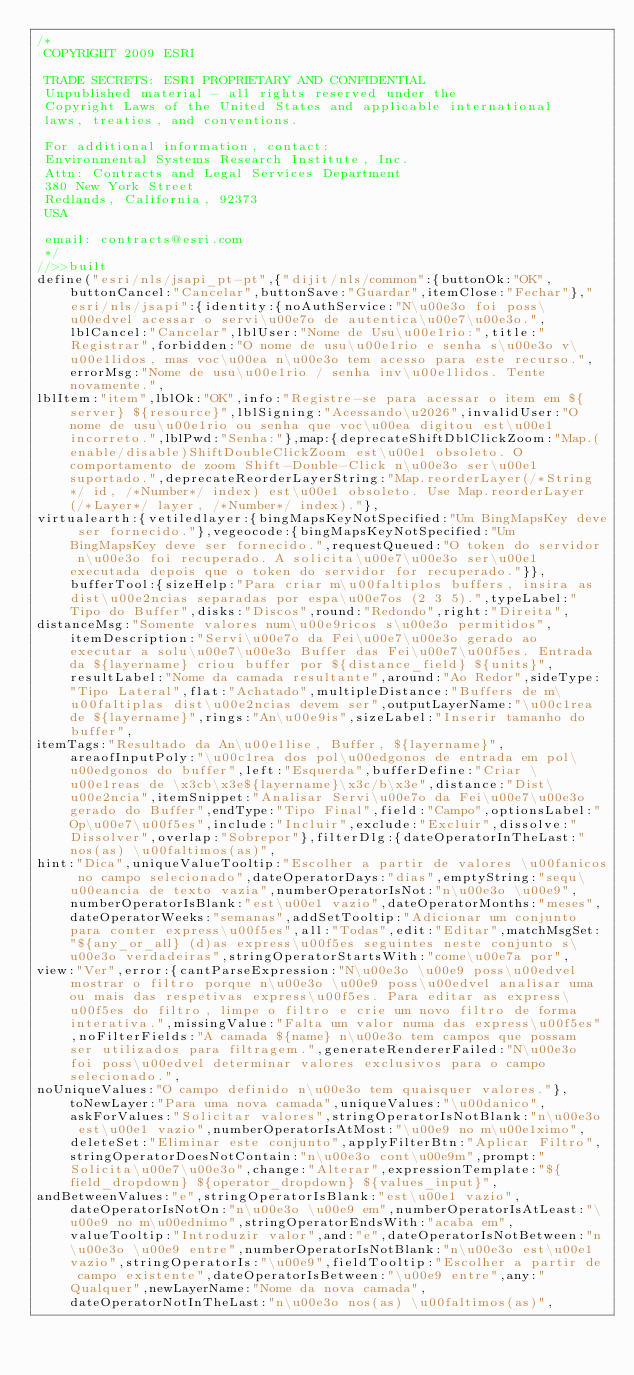<code> <loc_0><loc_0><loc_500><loc_500><_JavaScript_>/*
 COPYRIGHT 2009 ESRI

 TRADE SECRETS: ESRI PROPRIETARY AND CONFIDENTIAL
 Unpublished material - all rights reserved under the
 Copyright Laws of the United States and applicable international
 laws, treaties, and conventions.

 For additional information, contact:
 Environmental Systems Research Institute, Inc.
 Attn: Contracts and Legal Services Department
 380 New York Street
 Redlands, California, 92373
 USA

 email: contracts@esri.com
 */
//>>built
define("esri/nls/jsapi_pt-pt",{"dijit/nls/common":{buttonOk:"OK",buttonCancel:"Cancelar",buttonSave:"Guardar",itemClose:"Fechar"},"esri/nls/jsapi":{identity:{noAuthService:"N\u00e3o foi poss\u00edvel acessar o servi\u00e7o de autentica\u00e7\u00e3o.",lblCancel:"Cancelar",lblUser:"Nome de Usu\u00e1rio:",title:"Registrar",forbidden:"O nome de usu\u00e1rio e senha s\u00e3o v\u00e1lidos, mas voc\u00ea n\u00e3o tem acesso para este recurso.",errorMsg:"Nome de usu\u00e1rio / senha inv\u00e1lidos. Tente novamente.",
lblItem:"item",lblOk:"OK",info:"Registre-se para acessar o item em ${server} ${resource}",lblSigning:"Acessando\u2026",invalidUser:"O nome de usu\u00e1rio ou senha que voc\u00ea digitou est\u00e1 incorreto.",lblPwd:"Senha:"},map:{deprecateShiftDblClickZoom:"Map.(enable/disable)ShiftDoubleClickZoom est\u00e1 obsoleto. O comportamento de zoom Shift-Double-Click n\u00e3o ser\u00e1 suportado.",deprecateReorderLayerString:"Map.reorderLayer(/*String*/ id, /*Number*/ index) est\u00e1 obsoleto. Use Map.reorderLayer(/*Layer*/ layer, /*Number*/ index)."},
virtualearth:{vetiledlayer:{bingMapsKeyNotSpecified:"Um BingMapsKey deve ser fornecido."},vegeocode:{bingMapsKeyNotSpecified:"Um BingMapsKey deve ser fornecido.",requestQueued:"O token do servidor n\u00e3o foi recuperado. A solicita\u00e7\u00e3o ser\u00e1 executada depois que o token do servidor for recuperado."}},bufferTool:{sizeHelp:"Para criar m\u00faltiplos buffers, insira as dist\u00e2ncias separadas por espa\u00e7os (2 3 5).",typeLabel:"Tipo do Buffer",disks:"Discos",round:"Redondo",right:"Direita",
distanceMsg:"Somente valores num\u00e9ricos s\u00e3o permitidos",itemDescription:"Servi\u00e7o da Fei\u00e7\u00e3o gerado ao executar a solu\u00e7\u00e3o Buffer das Fei\u00e7\u00f5es. Entrada da ${layername} criou buffer por ${distance_field} ${units}",resultLabel:"Nome da camada resultante",around:"Ao Redor",sideType:"Tipo Lateral",flat:"Achatado",multipleDistance:"Buffers de m\u00faltiplas dist\u00e2ncias devem ser",outputLayerName:"\u00c1rea de ${layername}",rings:"An\u00e9is",sizeLabel:"Inserir tamanho do buffer",
itemTags:"Resultado da An\u00e1lise, Buffer, ${layername}",areaofInputPoly:"\u00c1rea dos pol\u00edgonos de entrada em pol\u00edgonos do buffer",left:"Esquerda",bufferDefine:"Criar \u00e1reas de \x3cb\x3e${layername}\x3c/b\x3e",distance:"Dist\u00e2ncia",itemSnippet:"Analisar Servi\u00e7o da Fei\u00e7\u00e3o gerado do Buffer",endType:"Tipo Final",field:"Campo",optionsLabel:"Op\u00e7\u00f5es",include:"Incluir",exclude:"Excluir",dissolve:"Dissolver",overlap:"Sobrepor"},filterDlg:{dateOperatorInTheLast:"nos(as) \u00faltimos(as)",
hint:"Dica",uniqueValueTooltip:"Escolher a partir de valores \u00fanicos no campo selecionado",dateOperatorDays:"dias",emptyString:"sequ\u00eancia de texto vazia",numberOperatorIsNot:"n\u00e3o \u00e9",numberOperatorIsBlank:"est\u00e1 vazio",dateOperatorMonths:"meses",dateOperatorWeeks:"semanas",addSetTooltip:"Adicionar um conjunto para conter express\u00f5es",all:"Todas",edit:"Editar",matchMsgSet:"${any_or_all} (d)as express\u00f5es seguintes neste conjunto s\u00e3o verdadeiras",stringOperatorStartsWith:"come\u00e7a por",
view:"Ver",error:{cantParseExpression:"N\u00e3o \u00e9 poss\u00edvel mostrar o filtro porque n\u00e3o \u00e9 poss\u00edvel analisar uma ou mais das respetivas express\u00f5es. Para editar as express\u00f5es do filtro, limpe o filtro e crie um novo filtro de forma interativa.",missingValue:"Falta um valor numa das express\u00f5es",noFilterFields:"A camada ${name} n\u00e3o tem campos que possam ser utilizados para filtragem.",generateRendererFailed:"N\u00e3o foi poss\u00edvel determinar valores exclusivos para o campo selecionado.",
noUniqueValues:"O campo definido n\u00e3o tem quaisquer valores."},toNewLayer:"Para uma nova camada",uniqueValues:"\u00danico",askForValues:"Solicitar valores",stringOperatorIsNotBlank:"n\u00e3o est\u00e1 vazio",numberOperatorIsAtMost:"\u00e9 no m\u00e1ximo",deleteSet:"Eliminar este conjunto",applyFilterBtn:"Aplicar Filtro",stringOperatorDoesNotContain:"n\u00e3o cont\u00e9m",prompt:"Solicita\u00e7\u00e3o",change:"Alterar",expressionTemplate:"${field_dropdown} ${operator_dropdown} ${values_input}",
andBetweenValues:"e",stringOperatorIsBlank:"est\u00e1 vazio",dateOperatorIsNotOn:"n\u00e3o \u00e9 em",numberOperatorIsAtLeast:"\u00e9 no m\u00ednimo",stringOperatorEndsWith:"acaba em",valueTooltip:"Introduzir valor",and:"e",dateOperatorIsNotBetween:"n\u00e3o \u00e9 entre",numberOperatorIsNotBlank:"n\u00e3o est\u00e1 vazio",stringOperatorIs:"\u00e9",fieldTooltip:"Escolher a partir de campo existente",dateOperatorIsBetween:"\u00e9 entre",any:"Qualquer",newLayerName:"Nome da nova camada",dateOperatorNotInTheLast:"n\u00e3o nos(as) \u00faltimos(as)",</code> 